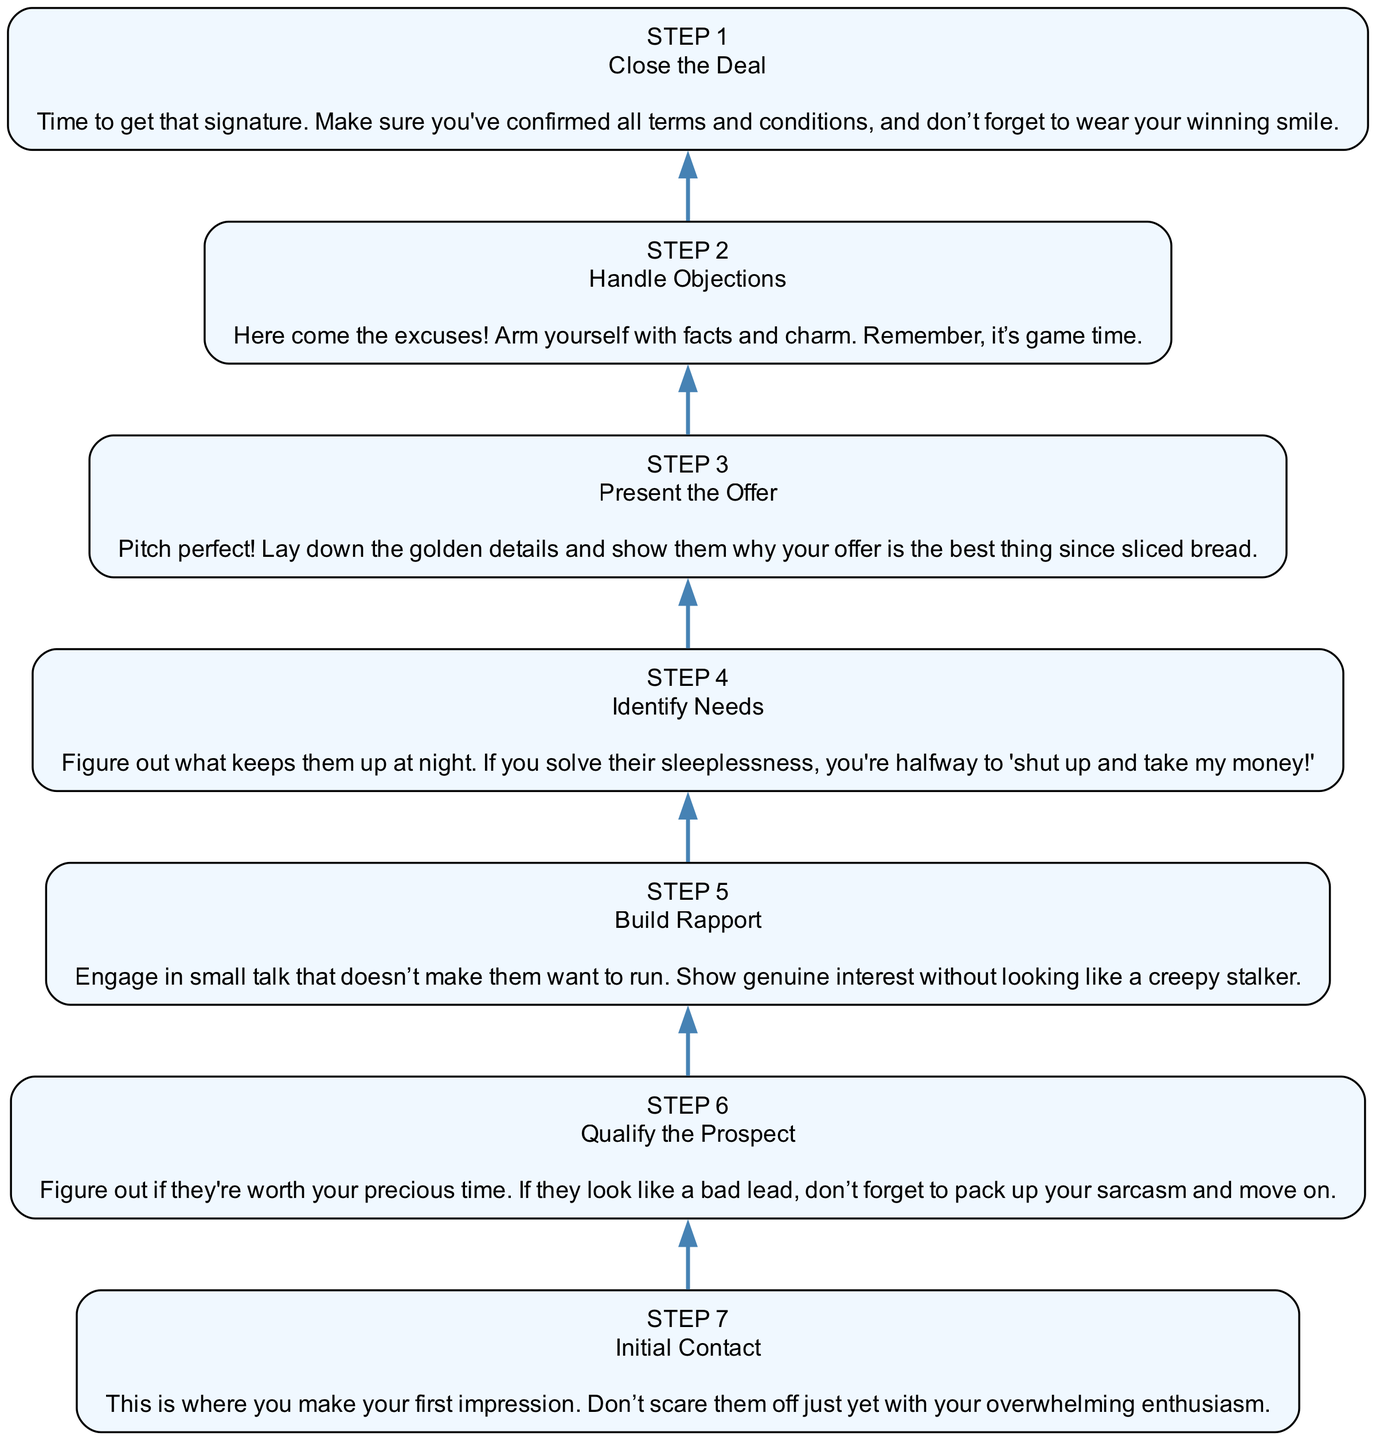What's the first step in closing a deal? The diagram starts with "Initial Contact," which is the first step indicated at the bottom.
Answer: Initial Contact How many total steps are there? By counting each step listed in the diagram from the bottom (Initial Contact) to the top (Close the Deal), there are a total of seven distinct steps.
Answer: 7 What comes after "Build Rapport"? According to the flow chart, "Build Rapport" leads to "Identify Needs," indicating the progression from creating a connection to understanding the client's needs.
Answer: Identify Needs Which step includes handling objections? The step titled "Handle Objections" is specifically labeled in the diagram and is two steps above "Present the Offer." It's the second step in the flow.
Answer: Handle Objections What is the primary goal of the "Present the Offer" step? In the diagram, "Present the Offer" is described as the step where the golden details are shown to convince the prospect of the offer’s value, thus making it a critical point for getting commitment.
Answer: To show the offer's value Explain the relationship between "Qualify the Prospect" and "Close the Deal." "Qualify the Prospect" is an earlier step that determines if the lead is worth pursuing further, while "Close the Deal" is the final action taken after navigating the previous steps successfully, including qualifying. If they aren’t qualified, it could lead to skipping the final step altogether.
Answer: Qualifying ensures a relevant lead for closing What step involves engaging in small talk? The diagram clearly states that "Build Rapport" is the step dedicated to small talk and engaging with the prospect without causing discomfort.
Answer: Build Rapport What condition must be met before moving from "Handle Objections" to "Close the Deal"? To transition from "Handle Objections" to "Close the Deal," all objections must have been satisfactorily addressed, allowing the process to continue towards finalizing the deal.
Answer: Addressing all objections 